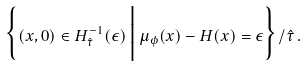<formula> <loc_0><loc_0><loc_500><loc_500>\Big \{ ( x , 0 ) \in H _ { \hat { \tau } } ^ { - 1 } ( \epsilon ) \, \Big | \, \mu _ { \phi } ( x ) - H ( x ) = \epsilon \Big \} / \hat { \tau } \, .</formula> 